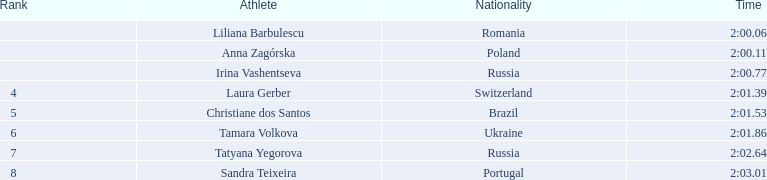Who were the participants in the athletic event? Liliana Barbulescu, 2:00.06, Anna Zagórska, 2:00.11, Irina Vashentseva, 2:00.77, Laura Gerber, 2:01.39, Christiane dos Santos, 2:01.53, Tamara Volkova, 2:01.86, Tatyana Yegorova, 2:02.64, Sandra Teixeira, 2:03.01. Who achieved second position? Anna Zagórska, 2:00.11. What was the duration of her performance? 2:00.11. 